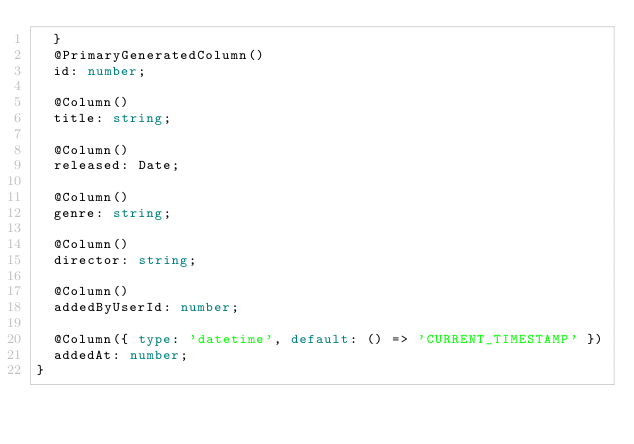Convert code to text. <code><loc_0><loc_0><loc_500><loc_500><_TypeScript_>  }
  @PrimaryGeneratedColumn()
  id: number;

  @Column()
  title: string;

  @Column()
  released: Date;

  @Column()
  genre: string;

  @Column()
  director: string;

  @Column()
  addedByUserId: number;

  @Column({ type: 'datetime', default: () => 'CURRENT_TIMESTAMP' })
  addedAt: number;
}
</code> 